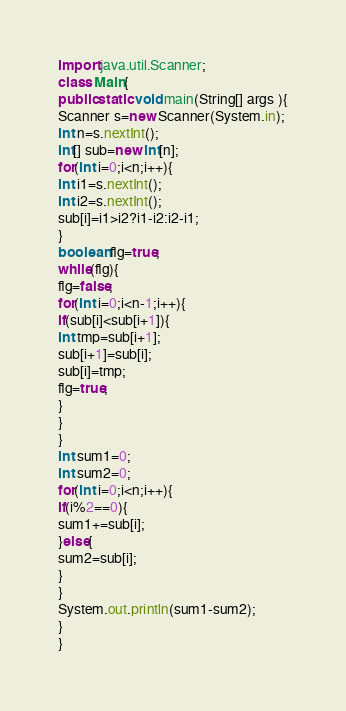Convert code to text. <code><loc_0><loc_0><loc_500><loc_500><_Java_>import java.util.Scanner;
class Main{
public static void main(String[] args ){
Scanner s=new Scanner(System.in);
int n=s.nextInt();
int[] sub=new int[n];
for(int i=0;i<n;i++){
int i1=s.nextInt();
int i2=s.nextInt();
sub[i]=i1>i2?i1-i2:i2-i1;
}
boolean flg=true;
while(flg){
flg=false;
for(int i=0;i<n-1;i++){
if(sub[i]<sub[i+1]){
int tmp=sub[i+1];
sub[i+1]=sub[i];
sub[i]=tmp;
flg=true;
}
}
}
int sum1=0;
int sum2=0;
for(int i=0;i<n;i++){
if(i%2==0){
sum1+=sub[i];
}else{
sum2=sub[i];
}
}
System.out.println(sum1-sum2);
} 
}</code> 